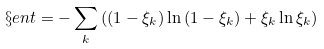<formula> <loc_0><loc_0><loc_500><loc_500>\S e n t = - \sum _ { k } { \left ( ( 1 - \xi _ { k } ) \ln { ( 1 - \xi _ { k } ) } + \xi _ { k } \ln { \xi _ { k } } \right ) }</formula> 